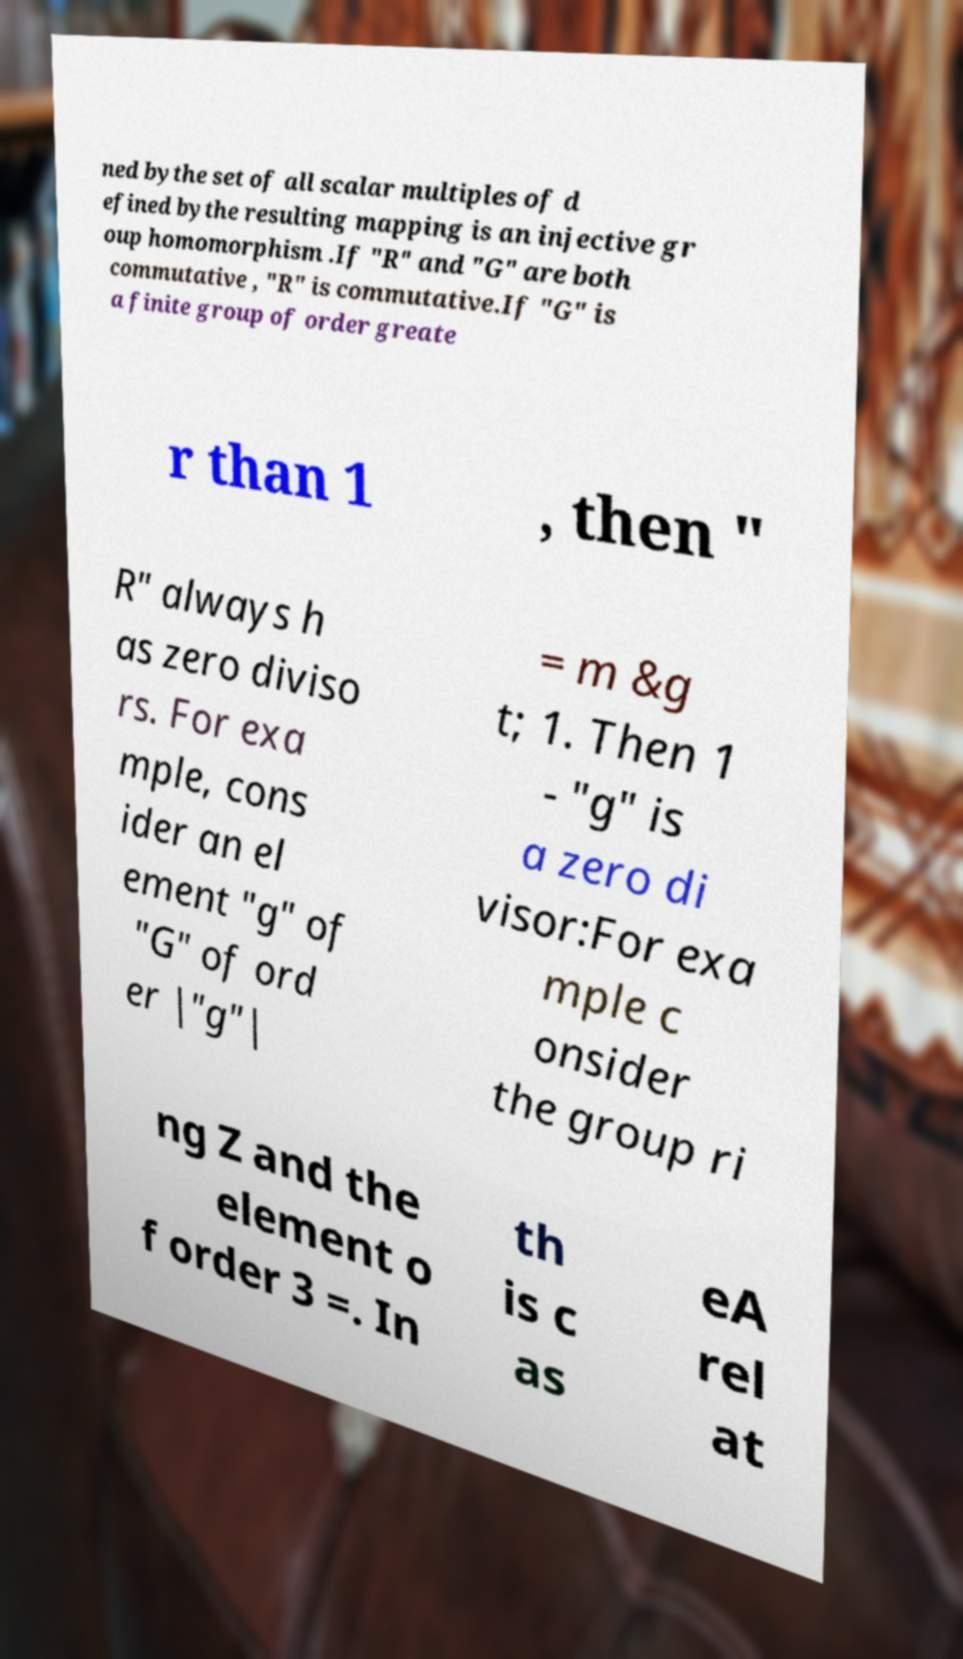For documentation purposes, I need the text within this image transcribed. Could you provide that? ned bythe set of all scalar multiples of d efined bythe resulting mapping is an injective gr oup homomorphism .If "R" and "G" are both commutative , "R" is commutative.If "G" is a finite group of order greate r than 1 , then " R" always h as zero diviso rs. For exa mple, cons ider an el ement "g" of "G" of ord er |"g"| = m &g t; 1. Then 1 - "g" is a zero di visor:For exa mple c onsider the group ri ng Z and the element o f order 3 =. In th is c as eA rel at 